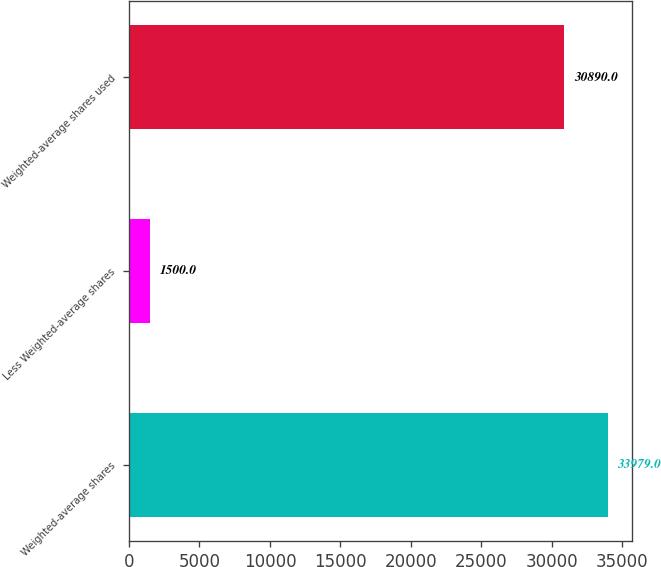<chart> <loc_0><loc_0><loc_500><loc_500><bar_chart><fcel>Weighted-average shares<fcel>Less Weighted-average shares<fcel>Weighted-average shares used<nl><fcel>33979<fcel>1500<fcel>30890<nl></chart> 